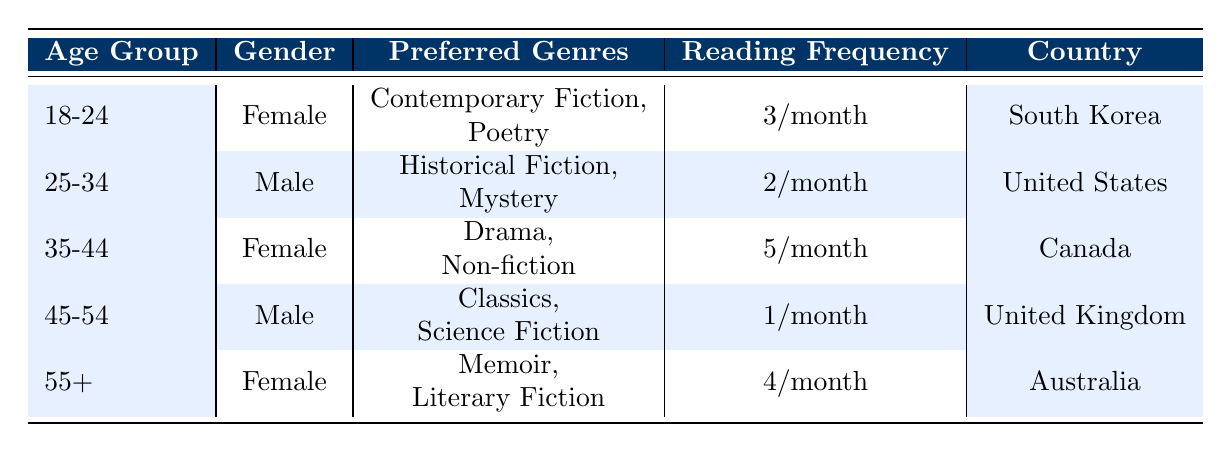What is the reading frequency of females aged 35-44? According to the table, the reading frequency for females in the age group of 35-44 is listed as 5/month.
Answer: 5/month Which country has a male reader aged 25-34? The table indicates that the male reader in the age group of 25-34 is from the United States.
Answer: United States How many individuals prefer “Memoir” as a genre? Examining the table, only one individual from the age group of 55+ prefers "Memoir."
Answer: 1 What is the average reading frequency for readers aged 18-24 and 55+? The reading frequency for the age group 18-24 is 3/month and for 55+ is 4/month. To find the average: (3 + 4) / 2 = 3.5.
Answer: 3.5/month Is there a male reader in the age group of 45-54? The table shows that there is indeed a male reader in the age group of 45-54.
Answer: Yes How many readers from Canada read more than 3 books per month? The table lists one individual, a female aged 35-44 from Canada, who reads 5 books per month, which is more than 3. There are no other entries from Canada with a higher reading frequency.
Answer: 1 Which gender has the highest reading frequency per month? Upon examining the reading frequencies: females aged 35-44 read 5/month, which is the highest compared to other entries. Hence, females have the highest reading frequency.
Answer: Female What is the total number of readers from South Korea and Australia? The table states that there is 1 reader from South Korea and 1 from Australia, summing them gives 1 + 1 = 2.
Answer: 2 Do any readers from the United Kingdom prefer "Science Fiction"? The table indicates that there is a male reader from the United Kingdom who prefers "Science Fiction."
Answer: Yes 